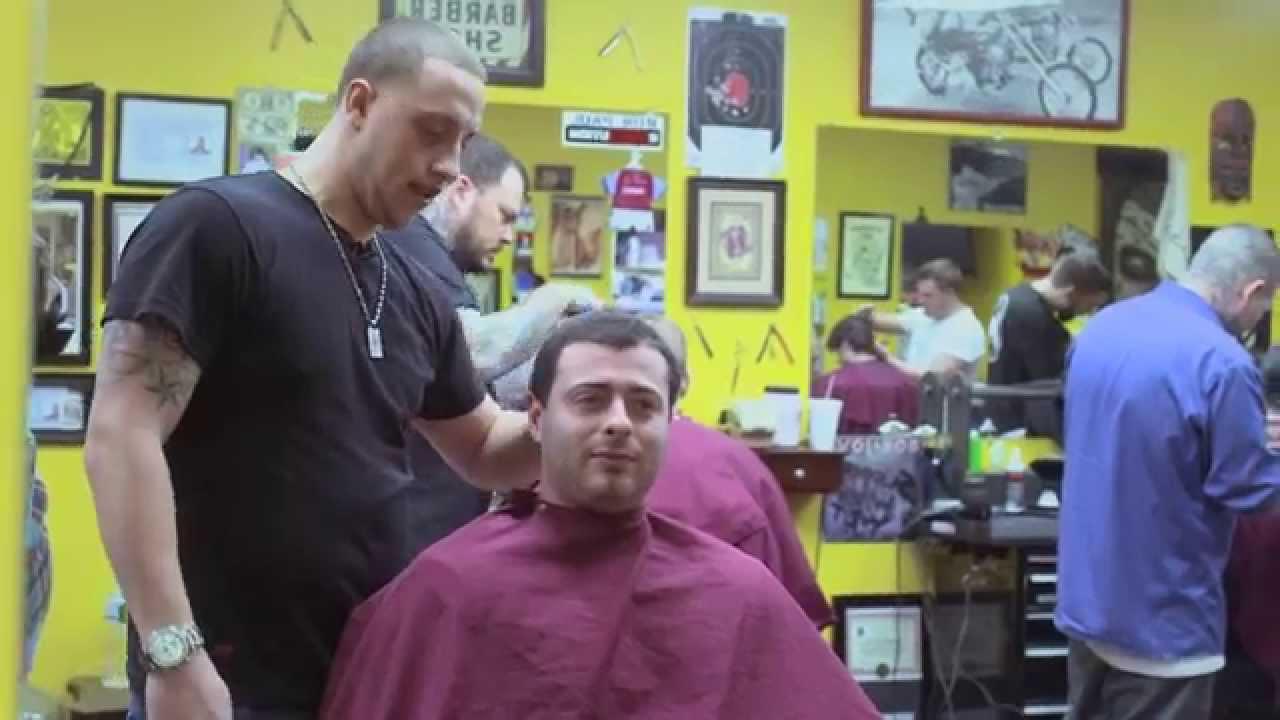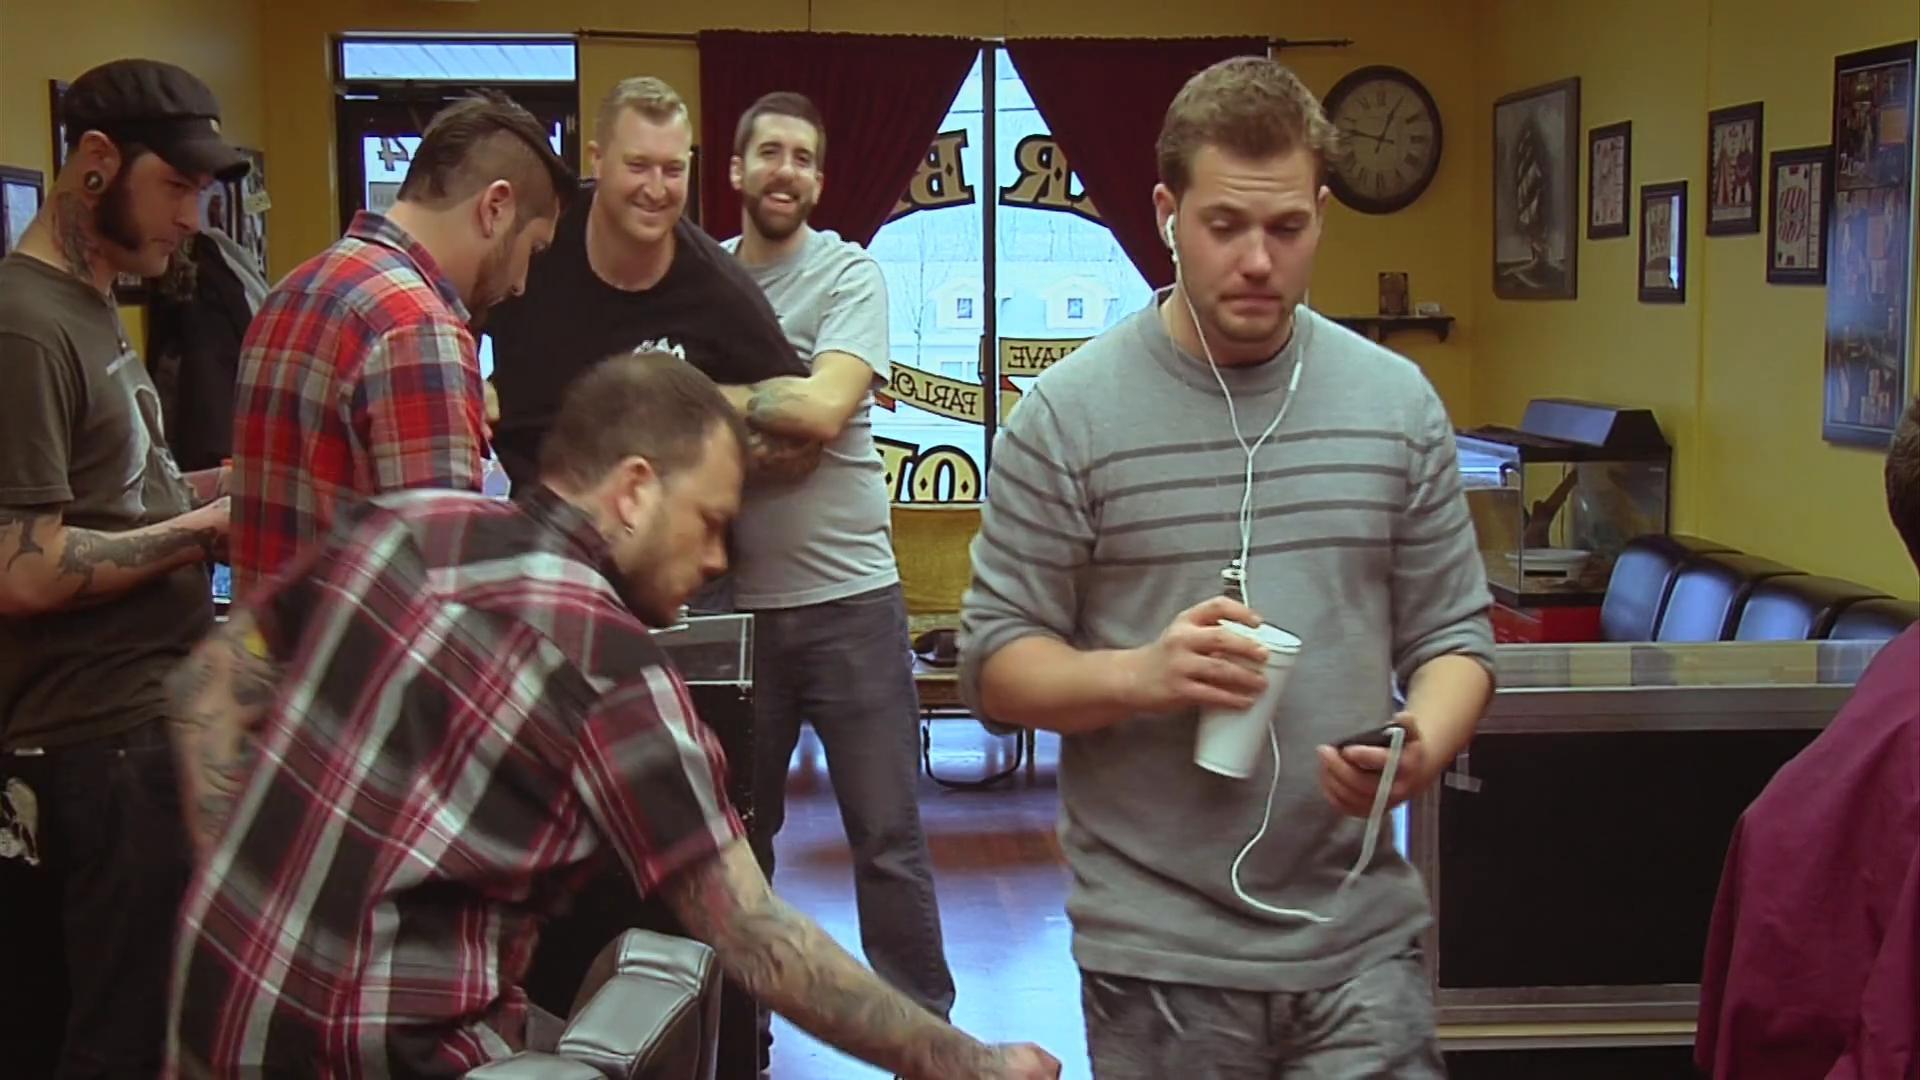The first image is the image on the left, the second image is the image on the right. Examine the images to the left and right. Is the description "An image shows just one young male customer with upswept hair." accurate? Answer yes or no. No. The first image is the image on the left, the second image is the image on the right. Examine the images to the left and right. Is the description "There is at least one empty chair shown." accurate? Answer yes or no. No. 